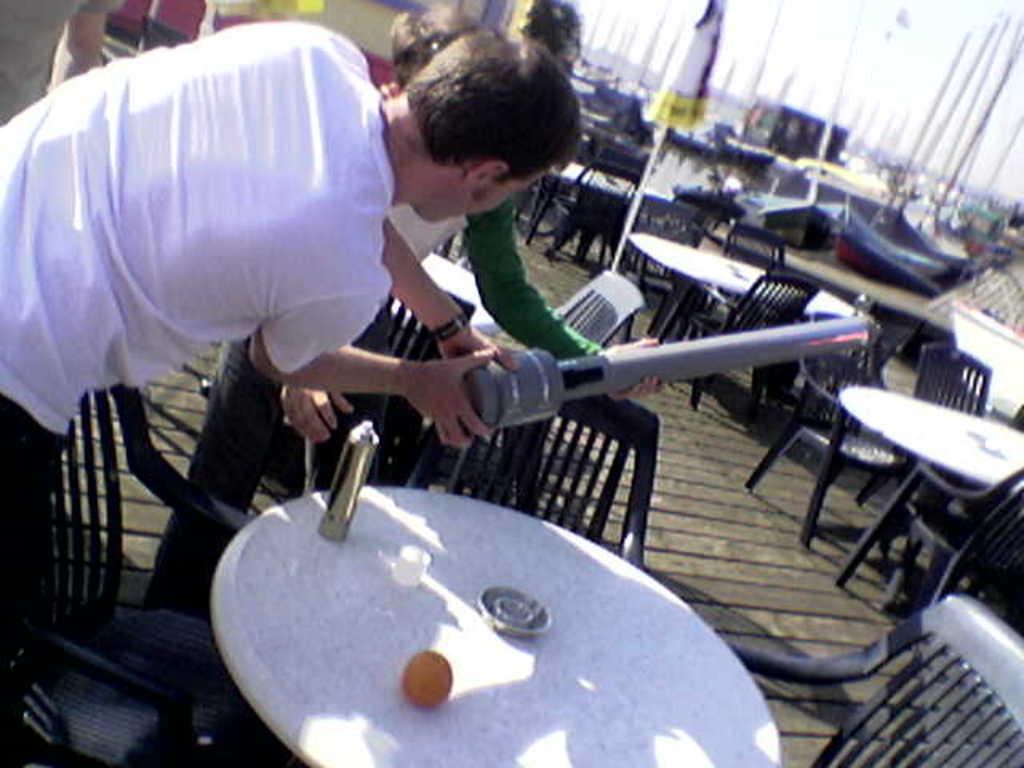Can you describe this image briefly? Here in this picture we can see number of tables and chairs present on the floor over there and in the front we can see a couple of men standing and holding something in their hand over there and we can also see an umbrella present in the middle over there and we can also see boats present over there. 